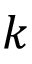Convert formula to latex. <formula><loc_0><loc_0><loc_500><loc_500>k</formula> 